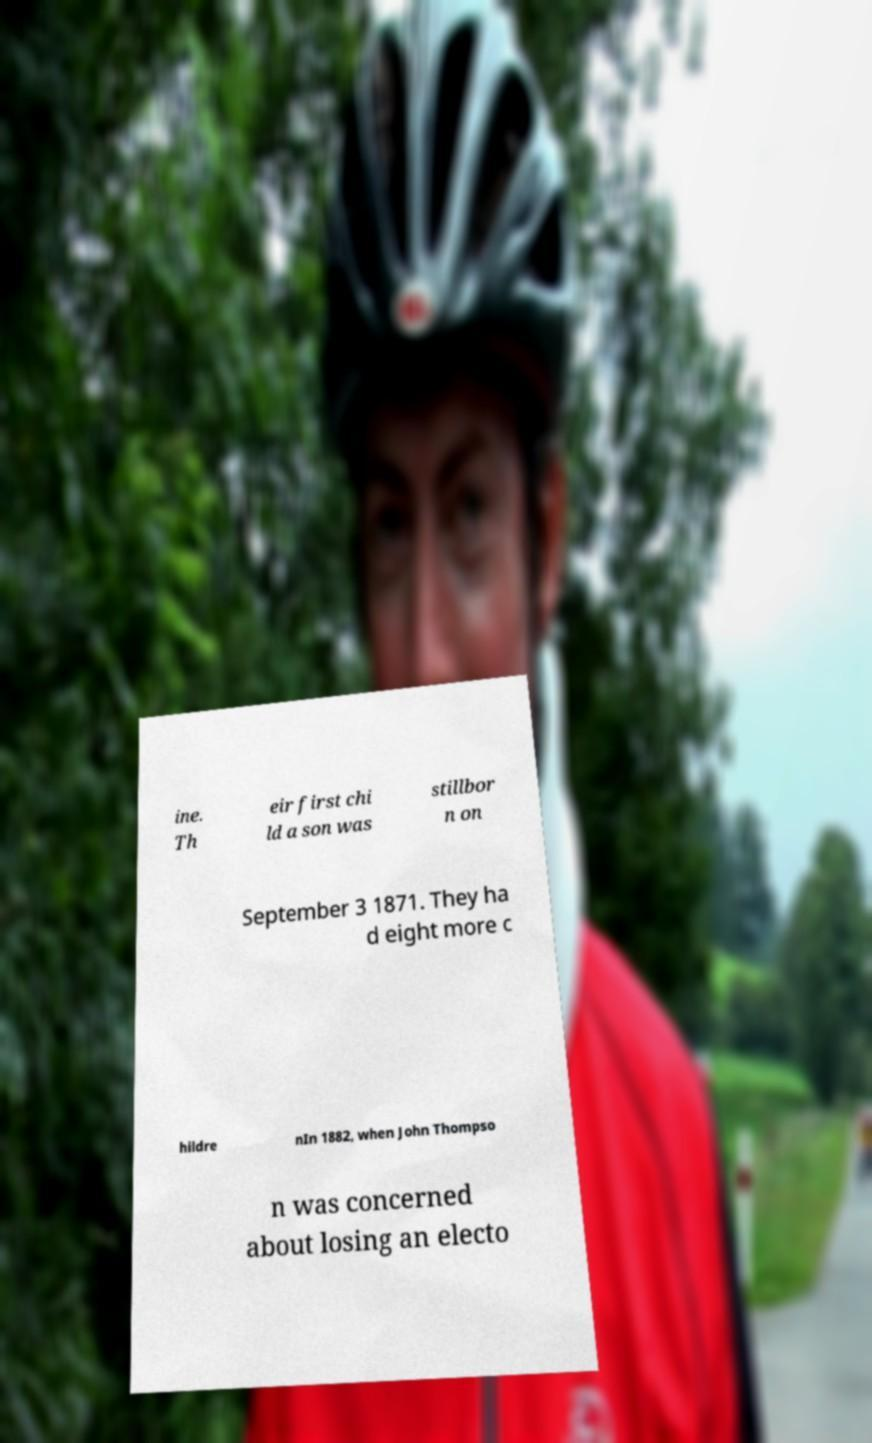Please read and relay the text visible in this image. What does it say? ine. Th eir first chi ld a son was stillbor n on September 3 1871. They ha d eight more c hildre nIn 1882, when John Thompso n was concerned about losing an electo 